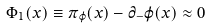<formula> <loc_0><loc_0><loc_500><loc_500>\Phi _ { 1 } ( x ) \equiv \pi _ { \varphi } ( x ) - \partial _ { - } \varphi ( x ) \approx 0</formula> 